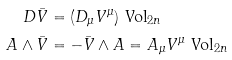<formula> <loc_0><loc_0><loc_500><loc_500>D \bar { V } & = ( D _ { \mu } V ^ { \mu } ) \ \text {Vol} _ { 2 n } \\ A \wedge \bar { V } & = - \bar { V } \wedge A = A _ { \mu } V ^ { \mu } \ \text {Vol} _ { 2 n } \\</formula> 